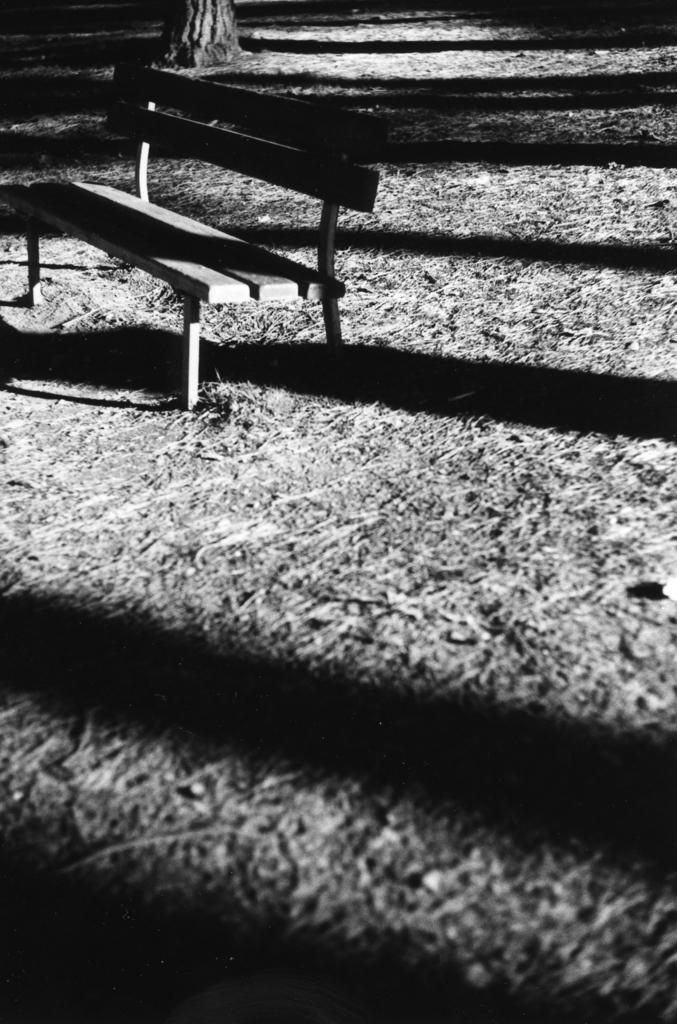Describe this image in one or two sentences. This is a black and white image. In the center of the image we can see a bench. At the top of the image we can see a tree. In the background of the image we can see the ground. 